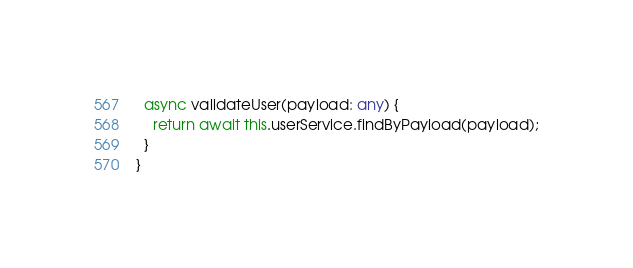Convert code to text. <code><loc_0><loc_0><loc_500><loc_500><_TypeScript_>  async validateUser(payload: any) {
    return await this.userService.findByPayload(payload);
  }
}
</code> 